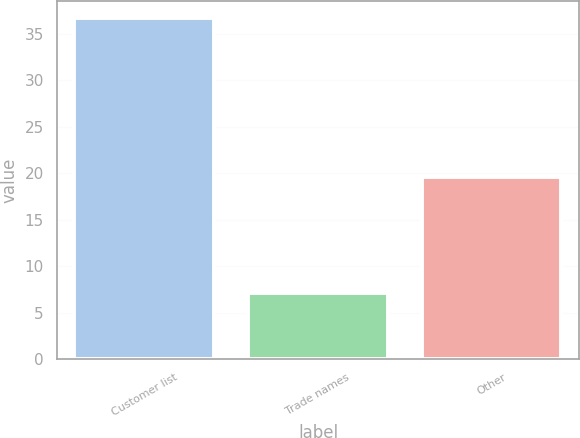<chart> <loc_0><loc_0><loc_500><loc_500><bar_chart><fcel>Customer list<fcel>Trade names<fcel>Other<nl><fcel>36.7<fcel>7.1<fcel>19.6<nl></chart> 